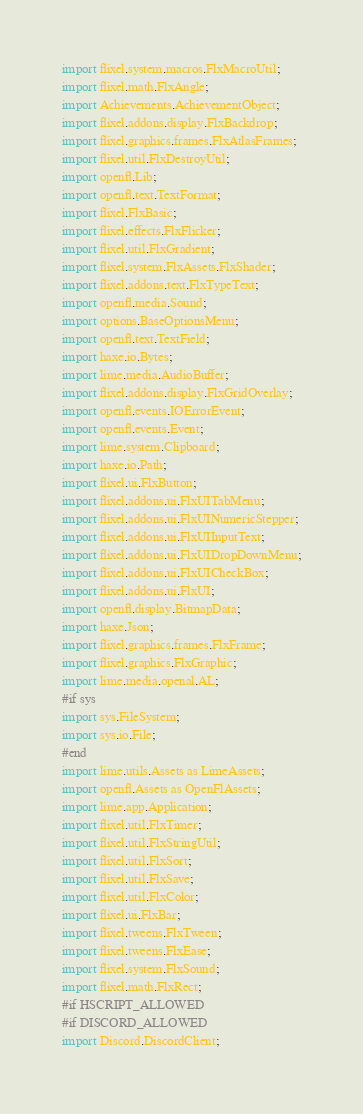Convert code to text. <code><loc_0><loc_0><loc_500><loc_500><_Haxe_>import flixel.system.macros.FlxMacroUtil;
import flixel.math.FlxAngle;
import Achievements.AchievementObject;
import flixel.addons.display.FlxBackdrop;
import flixel.graphics.frames.FlxAtlasFrames;
import flixel.util.FlxDestroyUtil;
import openfl.Lib;
import openfl.text.TextFormat;
import flixel.FlxBasic;
import flixel.effects.FlxFlicker;
import flixel.util.FlxGradient;
import flixel.system.FlxAssets.FlxShader;
import flixel.addons.text.FlxTypeText;
import openfl.media.Sound;
import options.BaseOptionsMenu;
import openfl.text.TextField;
import haxe.io.Bytes;
import lime.media.AudioBuffer;
import flixel.addons.display.FlxGridOverlay;
import openfl.events.IOErrorEvent;
import openfl.events.Event;
import lime.system.Clipboard;
import haxe.io.Path;
import flixel.ui.FlxButton;
import flixel.addons.ui.FlxUITabMenu;
import flixel.addons.ui.FlxUINumericStepper;
import flixel.addons.ui.FlxUIInputText;
import flixel.addons.ui.FlxUIDropDownMenu;
import flixel.addons.ui.FlxUICheckBox;
import flixel.addons.ui.FlxUI;
import openfl.display.BitmapData;
import haxe.Json;
import flixel.graphics.frames.FlxFrame;
import flixel.graphics.FlxGraphic;
import lime.media.openal.AL;
#if sys
import sys.FileSystem;
import sys.io.File;
#end
import lime.utils.Assets as LimeAssets;
import openfl.Assets as OpenFlAssets;
import lime.app.Application;
import flixel.util.FlxTimer;
import flixel.util.FlxStringUtil;
import flixel.util.FlxSort;
import flixel.util.FlxSave;
import flixel.util.FlxColor;
import flixel.ui.FlxBar;
import flixel.tweens.FlxTween;
import flixel.tweens.FlxEase;
import flixel.system.FlxSound;
import flixel.math.FlxRect;
#if HSCRIPT_ALLOWED
#if DISCORD_ALLOWED
import Discord.DiscordClient;</code> 